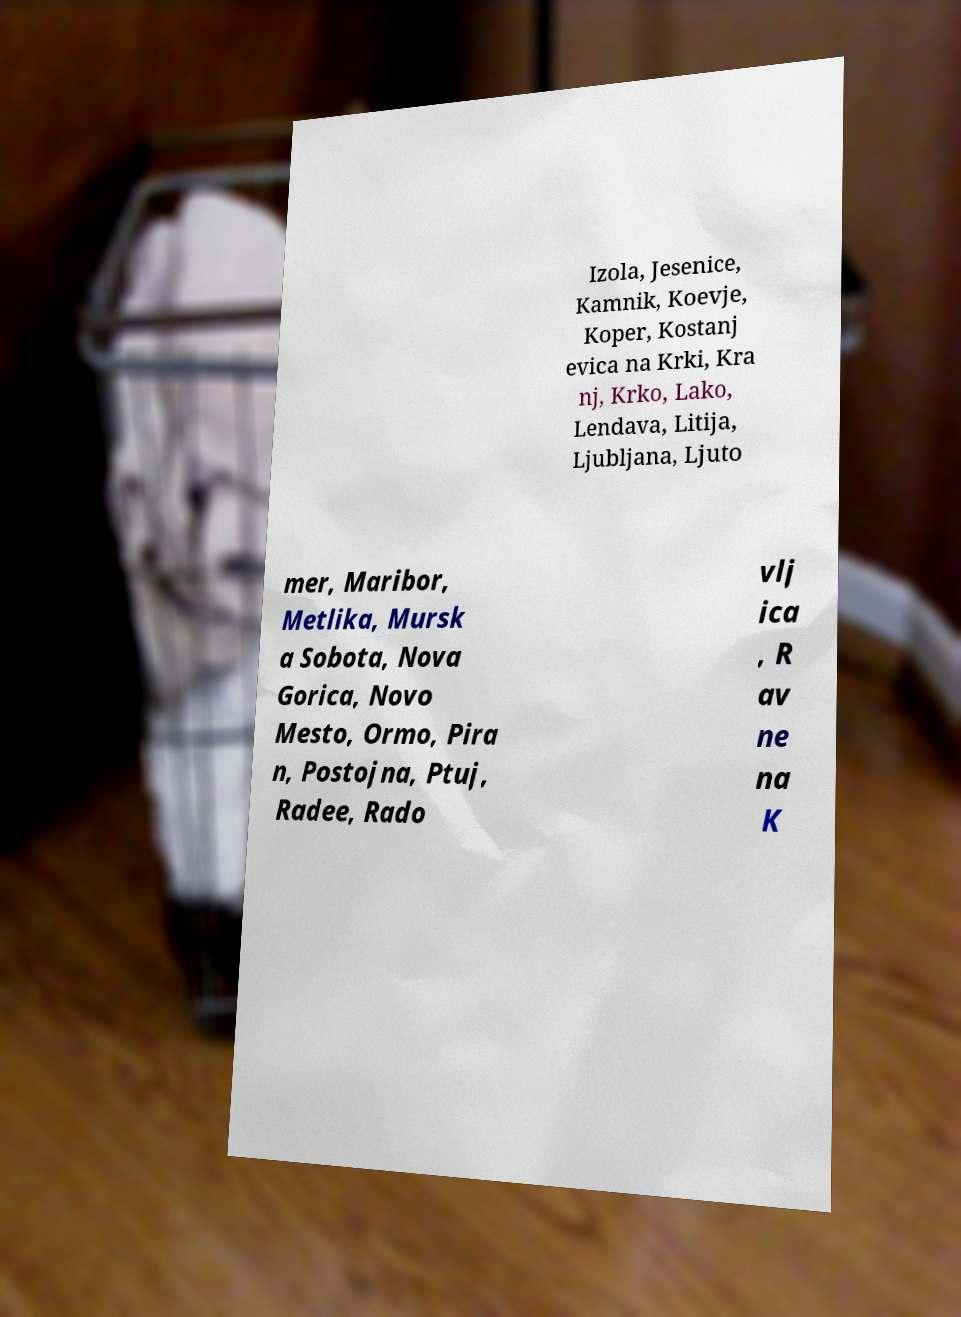What messages or text are displayed in this image? I need them in a readable, typed format. Izola, Jesenice, Kamnik, Koevje, Koper, Kostanj evica na Krki, Kra nj, Krko, Lako, Lendava, Litija, Ljubljana, Ljuto mer, Maribor, Metlika, Mursk a Sobota, Nova Gorica, Novo Mesto, Ormo, Pira n, Postojna, Ptuj, Radee, Rado vlj ica , R av ne na K 